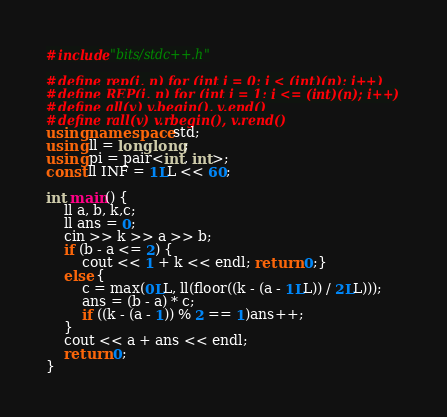Convert code to text. <code><loc_0><loc_0><loc_500><loc_500><_C++_>#include"bits/stdc++.h"

#define rep(i, n) for (int i = 0; i < (int)(n); i++)
#define REP(i, n) for (int i = 1; i <= (int)(n); i++)
#define all(v) v.begin(), v.end()
#define rall(v) v.rbegin(), v.rend()
using namespace std;
using ll = long long;
using pi = pair<int, int>;
const ll INF = 1LL << 60;

int main() {
	ll a, b, k,c;
	ll ans = 0;
	cin >> k >> a >> b;
	if (b - a <= 2) {
		cout << 1 + k << endl; return 0;}
	else {
		c = max(0LL, ll(floor((k - (a - 1LL)) / 2LL)));
		ans = (b - a) * c;
		if ((k - (a - 1)) % 2 == 1)ans++;
	}
	cout << a + ans << endl;
	return 0;
}

</code> 